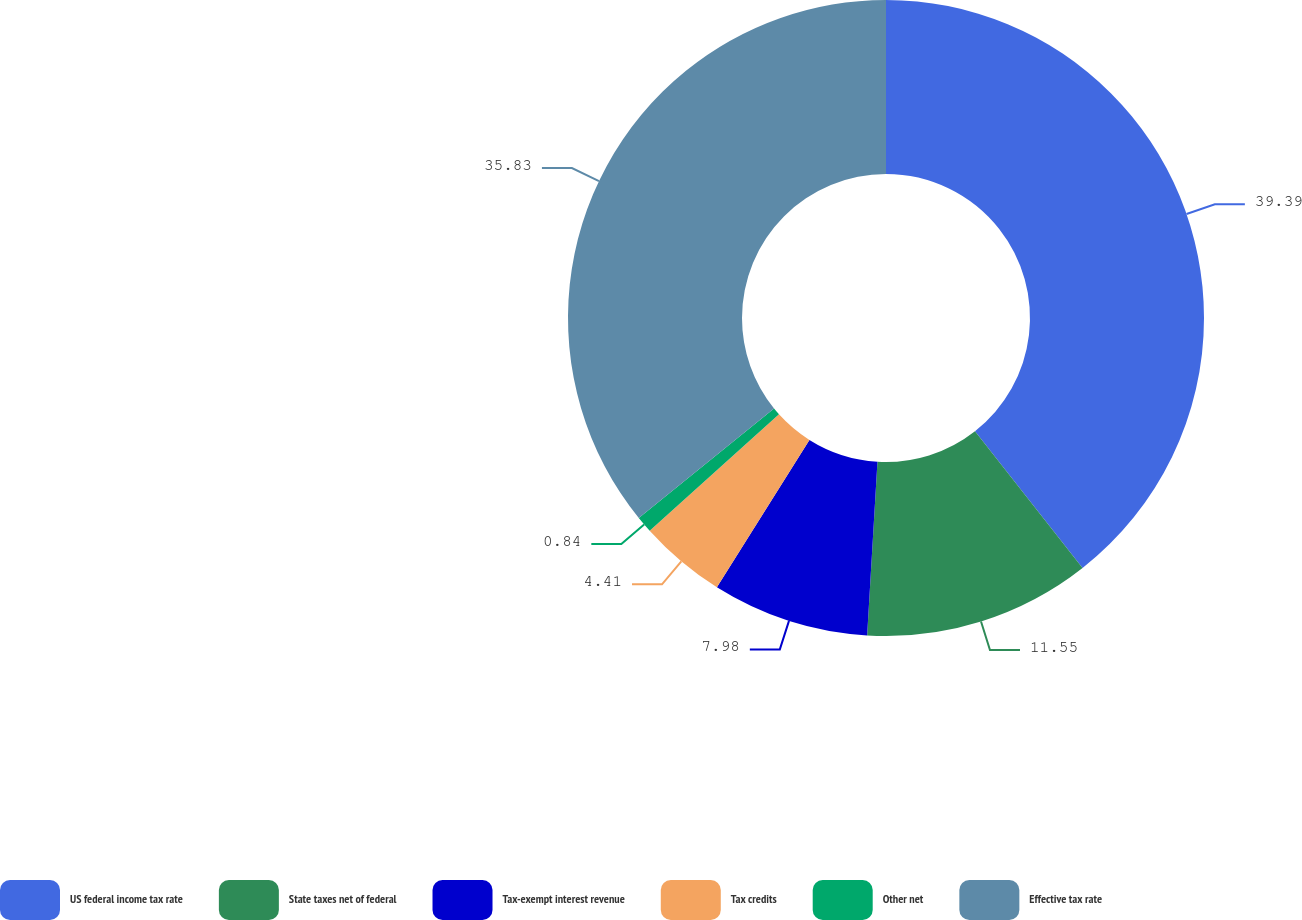Convert chart. <chart><loc_0><loc_0><loc_500><loc_500><pie_chart><fcel>US federal income tax rate<fcel>State taxes net of federal<fcel>Tax-exempt interest revenue<fcel>Tax credits<fcel>Other net<fcel>Effective tax rate<nl><fcel>39.4%<fcel>11.55%<fcel>7.98%<fcel>4.41%<fcel>0.84%<fcel>35.83%<nl></chart> 